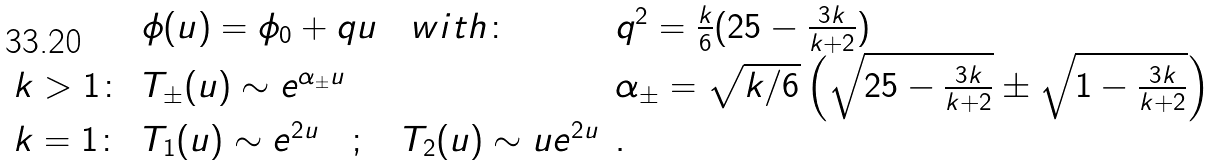<formula> <loc_0><loc_0><loc_500><loc_500>\begin{array} { l l l } & \phi ( u ) = \phi _ { 0 } + q u \quad w i t h \colon & q ^ { 2 } = \frac { k } { 6 } ( 2 5 - \frac { 3 k } { k + 2 } ) \\ k > 1 \colon & T _ { \pm } ( u ) \sim e ^ { \alpha _ { \pm } u } & \alpha _ { \pm } = \sqrt { k / 6 } \left ( \sqrt { 2 5 - \frac { 3 k } { k + 2 } } \pm \sqrt { 1 - \frac { 3 k } { k + 2 } } \right ) \\ k = 1 \colon & T _ { 1 } ( u ) \sim e ^ { 2 u } \quad ; \quad T _ { 2 } ( u ) \sim u e ^ { 2 u } & . \end{array}</formula> 